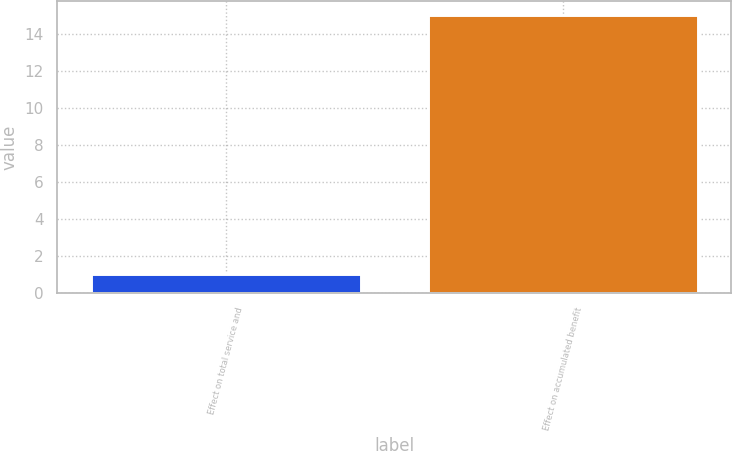Convert chart to OTSL. <chart><loc_0><loc_0><loc_500><loc_500><bar_chart><fcel>Effect on total service and<fcel>Effect on accumulated benefit<nl><fcel>1<fcel>15<nl></chart> 